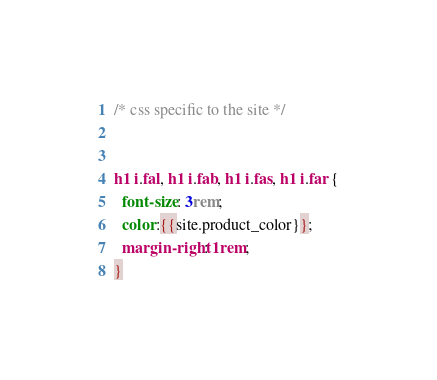<code> <loc_0><loc_0><loc_500><loc_500><_CSS_>
/* css specific to the site */


h1 i.fal, h1 i.fab, h1 i.fas, h1 i.far {
  font-size: 3rem;
  color:{{site.product_color}};
  margin-right: 1rem;
}



</code> 